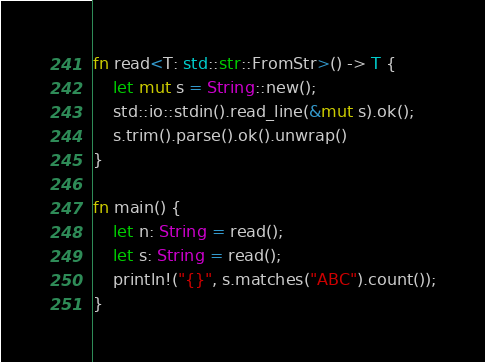Convert code to text. <code><loc_0><loc_0><loc_500><loc_500><_Rust_>fn read<T: std::str::FromStr>() -> T {
    let mut s = String::new();
    std::io::stdin().read_line(&mut s).ok();
    s.trim().parse().ok().unwrap()
}

fn main() {
    let n: String = read();
    let s: String = read();
    println!("{}", s.matches("ABC").count());
}
</code> 